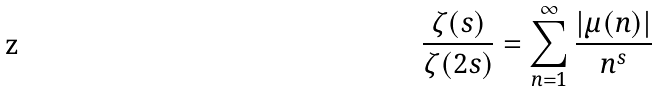<formula> <loc_0><loc_0><loc_500><loc_500>\frac { \zeta ( s ) } { \zeta ( 2 s ) } = \sum _ { n = 1 } ^ { \infty } \frac { | \mu ( n ) | } { n ^ { s } }</formula> 